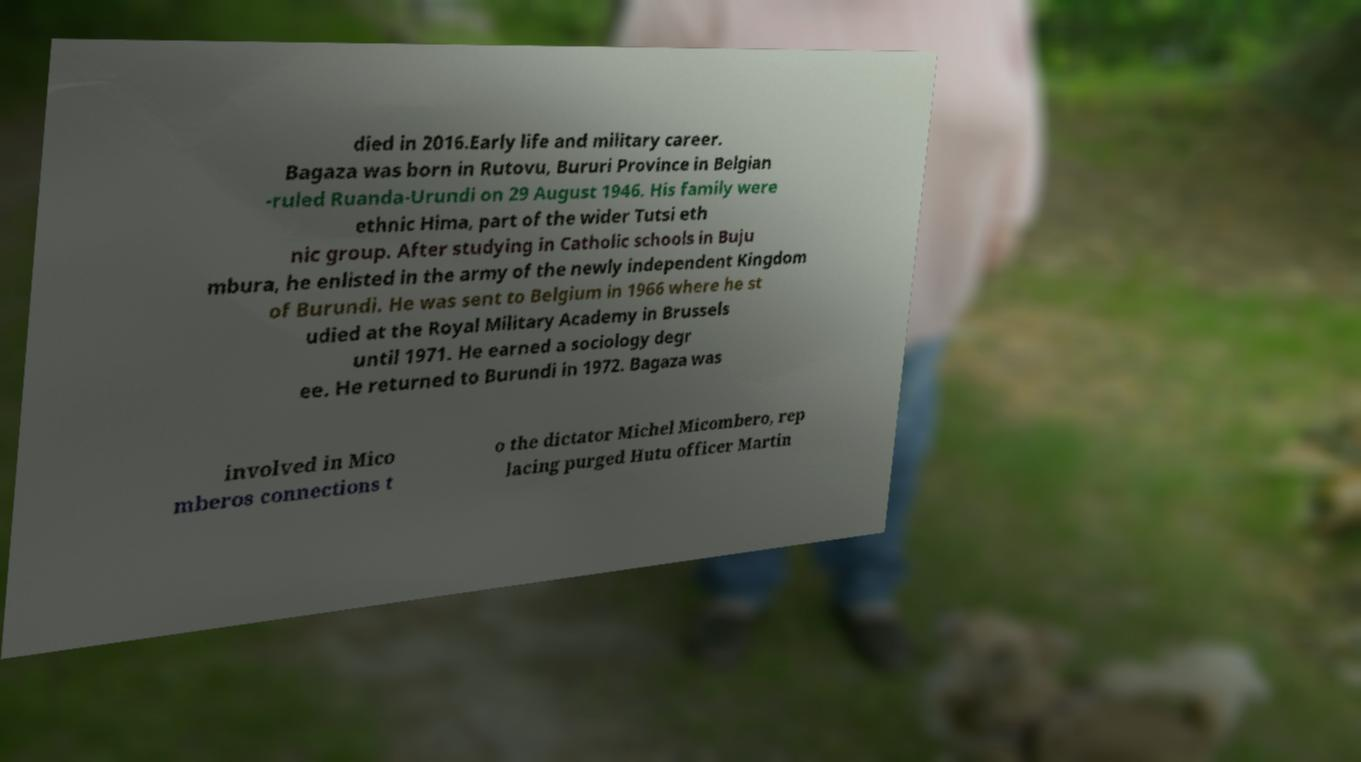For documentation purposes, I need the text within this image transcribed. Could you provide that? died in 2016.Early life and military career. Bagaza was born in Rutovu, Bururi Province in Belgian -ruled Ruanda-Urundi on 29 August 1946. His family were ethnic Hima, part of the wider Tutsi eth nic group. After studying in Catholic schools in Buju mbura, he enlisted in the army of the newly independent Kingdom of Burundi. He was sent to Belgium in 1966 where he st udied at the Royal Military Academy in Brussels until 1971. He earned a sociology degr ee. He returned to Burundi in 1972. Bagaza was involved in Mico mberos connections t o the dictator Michel Micombero, rep lacing purged Hutu officer Martin 